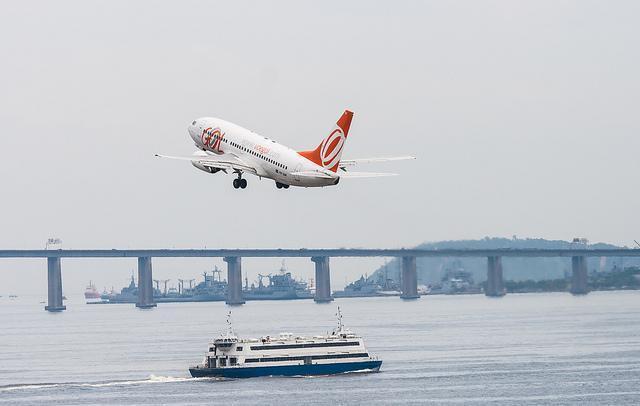What is the plane hovering over?
Indicate the correct choice and explain in the format: 'Answer: answer
Rationale: rationale.'
Options: Ladder, cat, baby carriage, boat. Answer: boat.
Rationale: The plane is by a boat. 